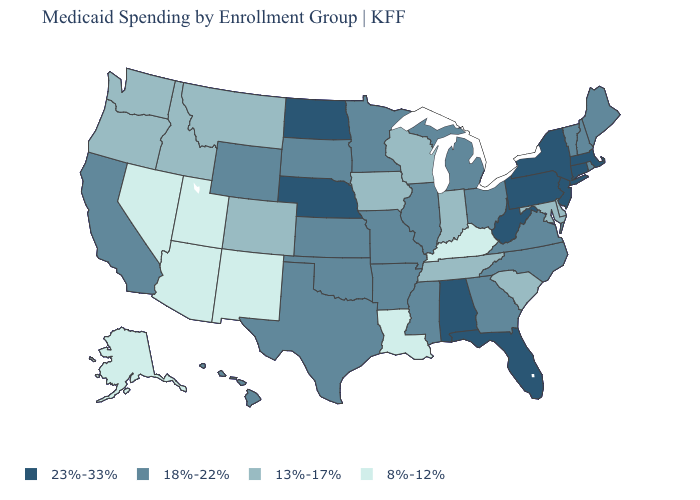What is the lowest value in the USA?
Be succinct. 8%-12%. Does Wyoming have the highest value in the West?
Keep it brief. Yes. What is the highest value in states that border Virginia?
Write a very short answer. 23%-33%. What is the value of California?
Answer briefly. 18%-22%. Does the map have missing data?
Be succinct. No. Name the states that have a value in the range 18%-22%?
Be succinct. Arkansas, California, Georgia, Hawaii, Illinois, Kansas, Maine, Michigan, Minnesota, Mississippi, Missouri, New Hampshire, North Carolina, Ohio, Oklahoma, Rhode Island, South Dakota, Texas, Vermont, Virginia, Wyoming. Which states hav the highest value in the West?
Short answer required. California, Hawaii, Wyoming. Does Virginia have the highest value in the South?
Be succinct. No. Which states have the highest value in the USA?
Write a very short answer. Alabama, Connecticut, Florida, Massachusetts, Nebraska, New Jersey, New York, North Dakota, Pennsylvania, West Virginia. How many symbols are there in the legend?
Concise answer only. 4. What is the value of Massachusetts?
Quick response, please. 23%-33%. What is the value of Colorado?
Give a very brief answer. 13%-17%. What is the value of Maine?
Concise answer only. 18%-22%. What is the highest value in the USA?
Short answer required. 23%-33%. Which states hav the highest value in the South?
Answer briefly. Alabama, Florida, West Virginia. 